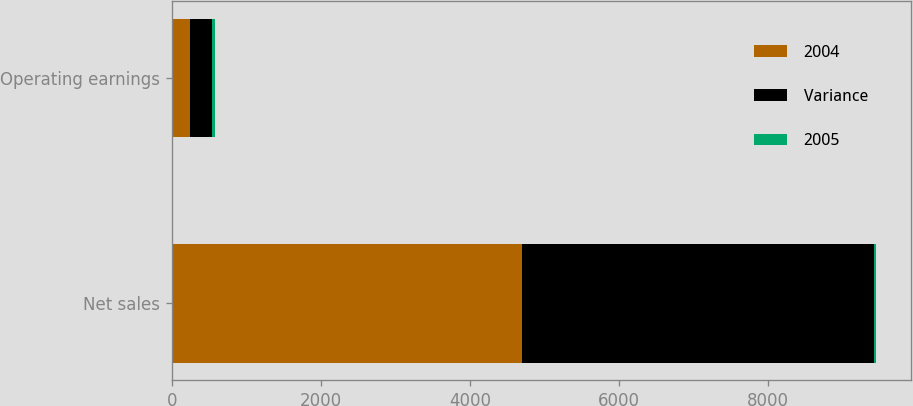<chart> <loc_0><loc_0><loc_500><loc_500><stacked_bar_chart><ecel><fcel>Net sales<fcel>Operating earnings<nl><fcel>2004<fcel>4695<fcel>249<nl><fcel>Variance<fcel>4726<fcel>292<nl><fcel>2005<fcel>31<fcel>43<nl></chart> 